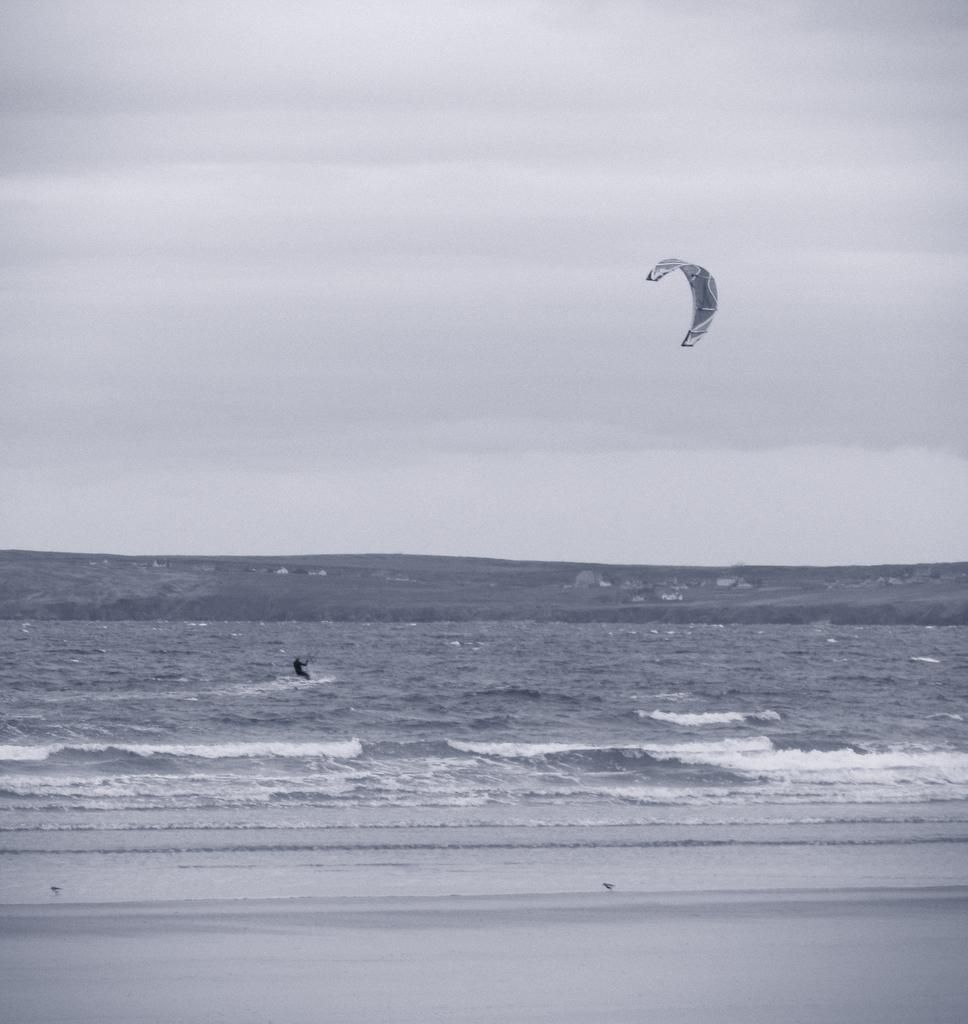What is the person in the image doing? The person is kitesurfing. Where is the kitesurfing taking place? The kitesurfing is taking place in the sea. What type of underwear is the person wearing while kitesurfing in the image? There is no information about the person's underwear in the image, and it is not visible. 